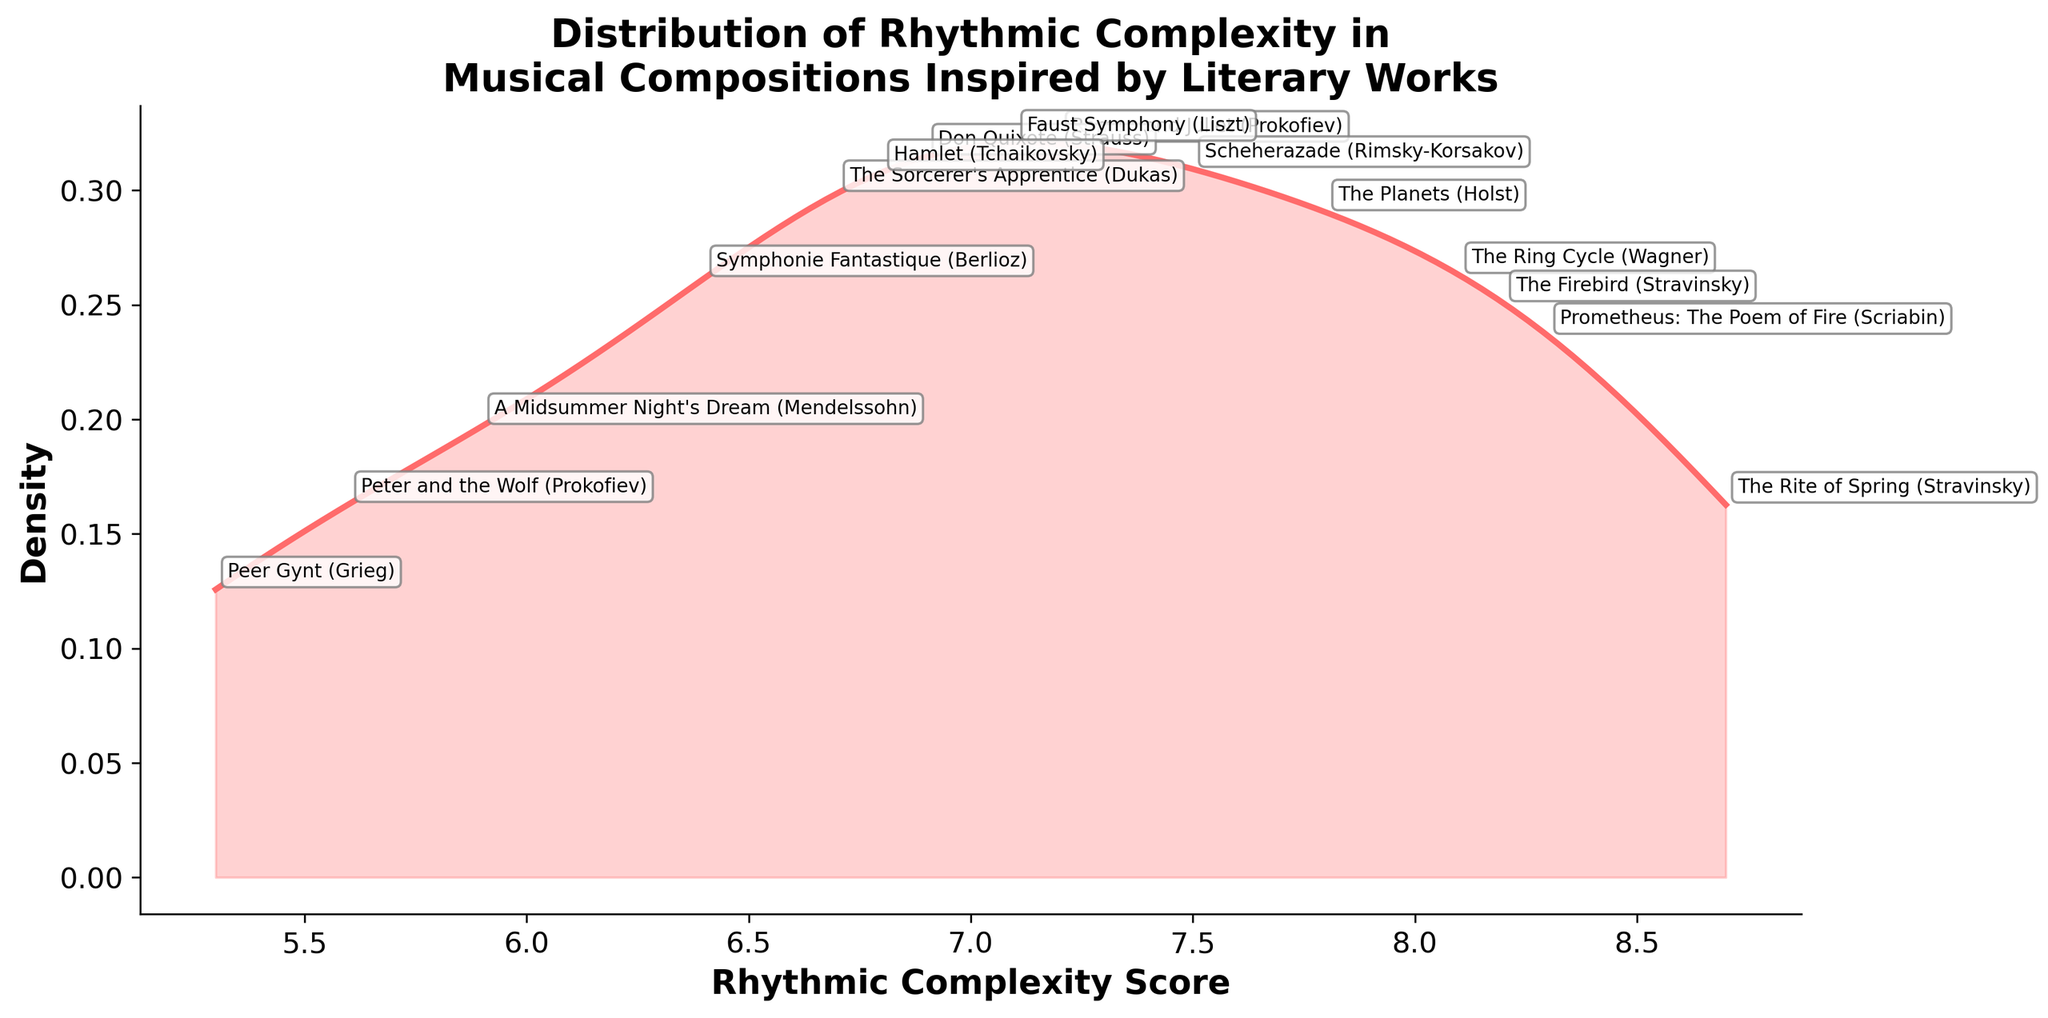what is the title of the figure? The title is located at the top of the figure and summarizes what the plot represents. By looking directly at it, we can see that the title is "Distribution of Rhythmic Complexity in Musical Compositions Inspired by Literary Works".
Answer: Distribution of Rhythmic Complexity in Musical Compositions Inspired by Literary Works what are the labels on the x-axis and y-axis? The axis labels are positioned near the respective axes of the plot. The x-axis is labeled "Rhythmic Complexity Score" and the y-axis is labeled "Density".
Answer: Rhythmic Complexity Score and Density how many compositions are annotated in the figure? Each annotation corresponds to a particular data point on the plot. By counting the number of annotations, we can determine there are 15 compositions annotated.
Answer: 15 what color is used for the density plot and the fill area beneath it? Observing the visual elements of the plot, the density curve is drawn in a reddish color, and a lighter, semi-transparent reddish color is used to fill the area beneath it.
Answer: Reddish color which composition has the highest rhythmic complexity score? By examining the density plot and referring to the annotations, the composition positioned furthest to the right is "The Rite of Spring" (Stravinsky) with a score of 8.7.
Answer: "The Rite of Spring" (Stravinsky) which composition has the lowest rhythmic complexity score? Looking at the annotations on the density plot, the composition positioned furthest to the left is "Peer Gynt" (Grieg) with a score of 5.3.
Answer: "Peer Gynt" (Grieg) what is the approximate value on the y-axis for the highest peak of the density plot? By finding the highest point on the density curve and tracing it horizontally to the y-axis, we can estimate the value. The highest peak approximates to around 0.16 on the y-axis.
Answer: 0.16 how many compositions have a rhythmic complexity score greater than 7? Counting the annotations with a rhythmic complexity score above 7, we find that there are 8 compositions: "The Rite of Spring", "Romeo and Juliet", "The Planets", "The Ring Cycle", "Scheherazade", "Prometheus: The Poem of Fire", "The Firebird", "Faust Symphony".
Answer: 8 compare the rhythmic complexity scores of "Romeo and Juliet" and "Hamlet". Which one is higher? Referring to the specific annotations on the density plot, "Romeo and Juliet" has a score of 7.2, while "Hamlet" has a score of 6.8. Therefore, "Romeo and Juliet" has a higher score.
Answer: "Romeo and Juliet" 